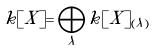<formula> <loc_0><loc_0><loc_500><loc_500>k [ X ] = \bigoplus _ { \lambda } k [ X ] _ { ( \lambda ) }</formula> 